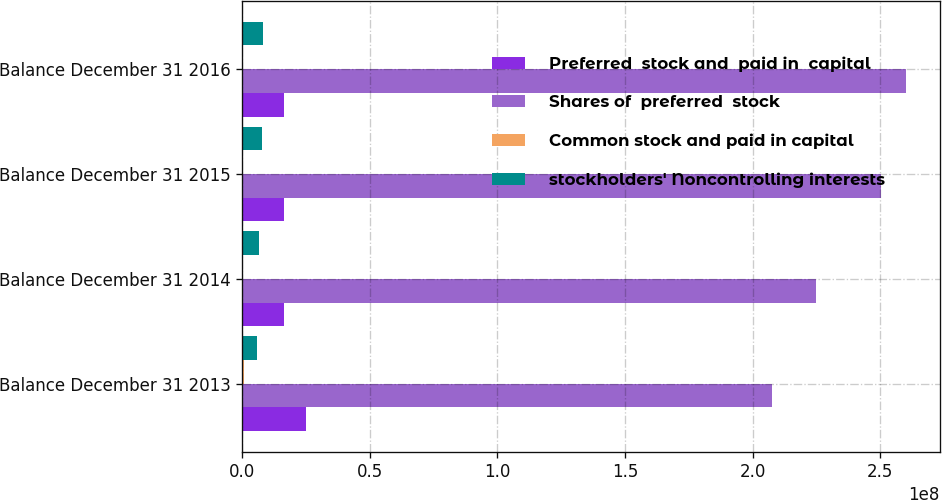Convert chart. <chart><loc_0><loc_0><loc_500><loc_500><stacked_bar_chart><ecel><fcel>Balance December 31 2013<fcel>Balance December 31 2014<fcel>Balance December 31 2015<fcel>Balance December 31 2016<nl><fcel>Preferred  stock and  paid in  capital<fcel>2.515e+07<fcel>1.635e+07<fcel>1.635e+07<fcel>1.635e+07<nl><fcel>Shares of  preferred  stock<fcel>2.07485e+08<fcel>2.24881e+08<fcel>2.50417e+08<fcel>2.60168e+08<nl><fcel>Common stock and paid in capital<fcel>609363<fcel>395378<fcel>395378<fcel>395378<nl><fcel>stockholders' Noncontrolling interests<fcel>5.76788e+06<fcel>6.46499e+06<fcel>7.66643e+06<fcel>8.22859e+06<nl></chart> 